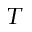<formula> <loc_0><loc_0><loc_500><loc_500>_ { T }</formula> 